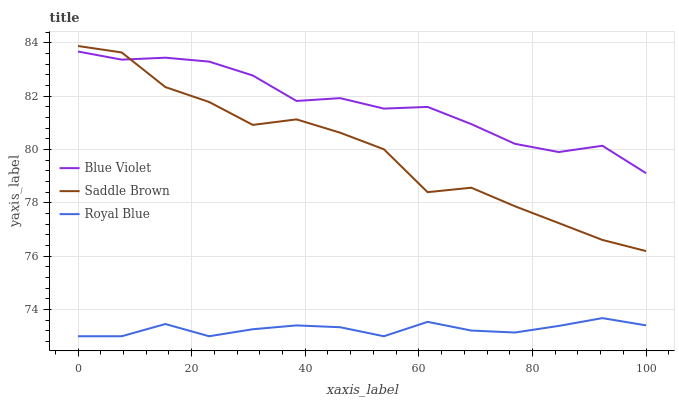Does Royal Blue have the minimum area under the curve?
Answer yes or no. Yes. Does Blue Violet have the maximum area under the curve?
Answer yes or no. Yes. Does Saddle Brown have the minimum area under the curve?
Answer yes or no. No. Does Saddle Brown have the maximum area under the curve?
Answer yes or no. No. Is Royal Blue the smoothest?
Answer yes or no. Yes. Is Saddle Brown the roughest?
Answer yes or no. Yes. Is Blue Violet the smoothest?
Answer yes or no. No. Is Blue Violet the roughest?
Answer yes or no. No. Does Royal Blue have the lowest value?
Answer yes or no. Yes. Does Saddle Brown have the lowest value?
Answer yes or no. No. Does Saddle Brown have the highest value?
Answer yes or no. Yes. Does Blue Violet have the highest value?
Answer yes or no. No. Is Royal Blue less than Saddle Brown?
Answer yes or no. Yes. Is Saddle Brown greater than Royal Blue?
Answer yes or no. Yes. Does Saddle Brown intersect Blue Violet?
Answer yes or no. Yes. Is Saddle Brown less than Blue Violet?
Answer yes or no. No. Is Saddle Brown greater than Blue Violet?
Answer yes or no. No. Does Royal Blue intersect Saddle Brown?
Answer yes or no. No. 